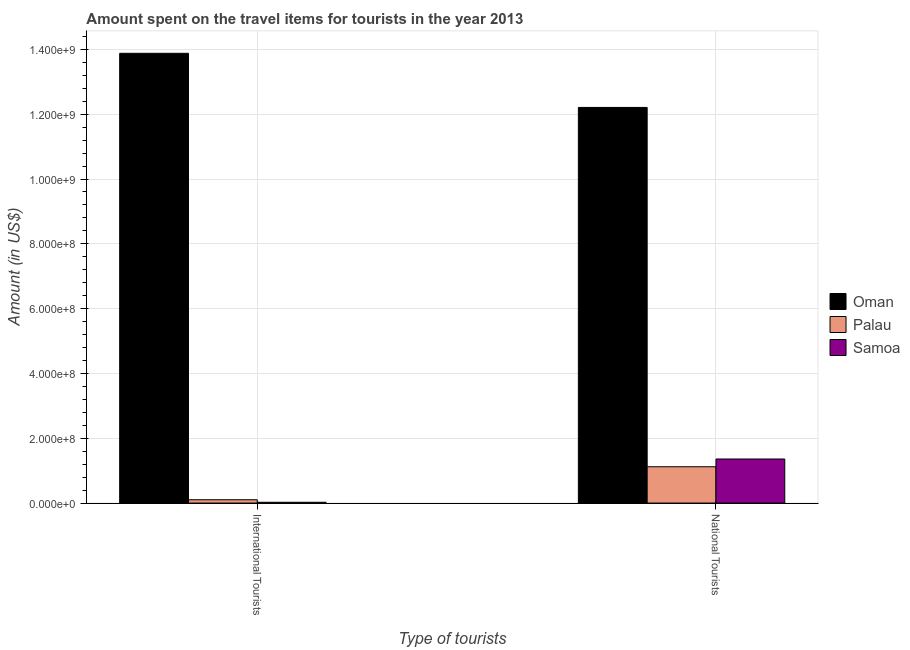How many groups of bars are there?
Keep it short and to the point. 2. What is the label of the 2nd group of bars from the left?
Your answer should be compact. National Tourists. What is the amount spent on travel items of national tourists in Palau?
Provide a succinct answer. 1.12e+08. Across all countries, what is the maximum amount spent on travel items of international tourists?
Ensure brevity in your answer.  1.39e+09. Across all countries, what is the minimum amount spent on travel items of national tourists?
Make the answer very short. 1.12e+08. In which country was the amount spent on travel items of national tourists maximum?
Keep it short and to the point. Oman. In which country was the amount spent on travel items of national tourists minimum?
Give a very brief answer. Palau. What is the total amount spent on travel items of national tourists in the graph?
Your answer should be very brief. 1.47e+09. What is the difference between the amount spent on travel items of national tourists in Samoa and that in Oman?
Ensure brevity in your answer.  -1.08e+09. What is the difference between the amount spent on travel items of international tourists in Oman and the amount spent on travel items of national tourists in Samoa?
Your answer should be compact. 1.25e+09. What is the average amount spent on travel items of national tourists per country?
Provide a succinct answer. 4.90e+08. What is the difference between the amount spent on travel items of national tourists and amount spent on travel items of international tourists in Samoa?
Ensure brevity in your answer.  1.34e+08. In how many countries, is the amount spent on travel items of international tourists greater than 1080000000 US$?
Offer a terse response. 1. What is the ratio of the amount spent on travel items of international tourists in Samoa to that in Oman?
Your response must be concise. 0. Is the amount spent on travel items of national tourists in Samoa less than that in Palau?
Give a very brief answer. No. What does the 1st bar from the left in International Tourists represents?
Make the answer very short. Oman. What does the 3rd bar from the right in International Tourists represents?
Make the answer very short. Oman. How many bars are there?
Offer a terse response. 6. Are all the bars in the graph horizontal?
Your response must be concise. No. Where does the legend appear in the graph?
Give a very brief answer. Center right. How are the legend labels stacked?
Make the answer very short. Vertical. What is the title of the graph?
Your answer should be compact. Amount spent on the travel items for tourists in the year 2013. What is the label or title of the X-axis?
Keep it short and to the point. Type of tourists. What is the label or title of the Y-axis?
Provide a short and direct response. Amount (in US$). What is the Amount (in US$) of Oman in International Tourists?
Offer a very short reply. 1.39e+09. What is the Amount (in US$) in Palau in International Tourists?
Provide a succinct answer. 1.02e+07. What is the Amount (in US$) in Samoa in International Tourists?
Keep it short and to the point. 2.40e+06. What is the Amount (in US$) in Oman in National Tourists?
Ensure brevity in your answer.  1.22e+09. What is the Amount (in US$) of Palau in National Tourists?
Provide a succinct answer. 1.12e+08. What is the Amount (in US$) in Samoa in National Tourists?
Offer a terse response. 1.36e+08. Across all Type of tourists, what is the maximum Amount (in US$) in Oman?
Your answer should be compact. 1.39e+09. Across all Type of tourists, what is the maximum Amount (in US$) of Palau?
Provide a short and direct response. 1.12e+08. Across all Type of tourists, what is the maximum Amount (in US$) in Samoa?
Provide a short and direct response. 1.36e+08. Across all Type of tourists, what is the minimum Amount (in US$) of Oman?
Keep it short and to the point. 1.22e+09. Across all Type of tourists, what is the minimum Amount (in US$) of Palau?
Your answer should be very brief. 1.02e+07. Across all Type of tourists, what is the minimum Amount (in US$) of Samoa?
Offer a terse response. 2.40e+06. What is the total Amount (in US$) of Oman in the graph?
Keep it short and to the point. 2.61e+09. What is the total Amount (in US$) in Palau in the graph?
Your answer should be compact. 1.22e+08. What is the total Amount (in US$) in Samoa in the graph?
Your response must be concise. 1.38e+08. What is the difference between the Amount (in US$) in Oman in International Tourists and that in National Tourists?
Provide a succinct answer. 1.67e+08. What is the difference between the Amount (in US$) of Palau in International Tourists and that in National Tourists?
Your answer should be very brief. -1.02e+08. What is the difference between the Amount (in US$) of Samoa in International Tourists and that in National Tourists?
Ensure brevity in your answer.  -1.34e+08. What is the difference between the Amount (in US$) in Oman in International Tourists and the Amount (in US$) in Palau in National Tourists?
Ensure brevity in your answer.  1.28e+09. What is the difference between the Amount (in US$) of Oman in International Tourists and the Amount (in US$) of Samoa in National Tourists?
Provide a short and direct response. 1.25e+09. What is the difference between the Amount (in US$) of Palau in International Tourists and the Amount (in US$) of Samoa in National Tourists?
Keep it short and to the point. -1.26e+08. What is the average Amount (in US$) of Oman per Type of tourists?
Your response must be concise. 1.30e+09. What is the average Amount (in US$) in Palau per Type of tourists?
Give a very brief answer. 6.11e+07. What is the average Amount (in US$) of Samoa per Type of tourists?
Provide a short and direct response. 6.92e+07. What is the difference between the Amount (in US$) in Oman and Amount (in US$) in Palau in International Tourists?
Give a very brief answer. 1.38e+09. What is the difference between the Amount (in US$) of Oman and Amount (in US$) of Samoa in International Tourists?
Your response must be concise. 1.39e+09. What is the difference between the Amount (in US$) in Palau and Amount (in US$) in Samoa in International Tourists?
Ensure brevity in your answer.  7.80e+06. What is the difference between the Amount (in US$) in Oman and Amount (in US$) in Palau in National Tourists?
Offer a terse response. 1.11e+09. What is the difference between the Amount (in US$) of Oman and Amount (in US$) of Samoa in National Tourists?
Provide a succinct answer. 1.08e+09. What is the difference between the Amount (in US$) of Palau and Amount (in US$) of Samoa in National Tourists?
Offer a terse response. -2.40e+07. What is the ratio of the Amount (in US$) of Oman in International Tourists to that in National Tourists?
Your answer should be very brief. 1.14. What is the ratio of the Amount (in US$) of Palau in International Tourists to that in National Tourists?
Offer a very short reply. 0.09. What is the ratio of the Amount (in US$) of Samoa in International Tourists to that in National Tourists?
Your response must be concise. 0.02. What is the difference between the highest and the second highest Amount (in US$) of Oman?
Your answer should be compact. 1.67e+08. What is the difference between the highest and the second highest Amount (in US$) in Palau?
Provide a succinct answer. 1.02e+08. What is the difference between the highest and the second highest Amount (in US$) of Samoa?
Your answer should be compact. 1.34e+08. What is the difference between the highest and the lowest Amount (in US$) of Oman?
Offer a very short reply. 1.67e+08. What is the difference between the highest and the lowest Amount (in US$) in Palau?
Your answer should be compact. 1.02e+08. What is the difference between the highest and the lowest Amount (in US$) in Samoa?
Your response must be concise. 1.34e+08. 